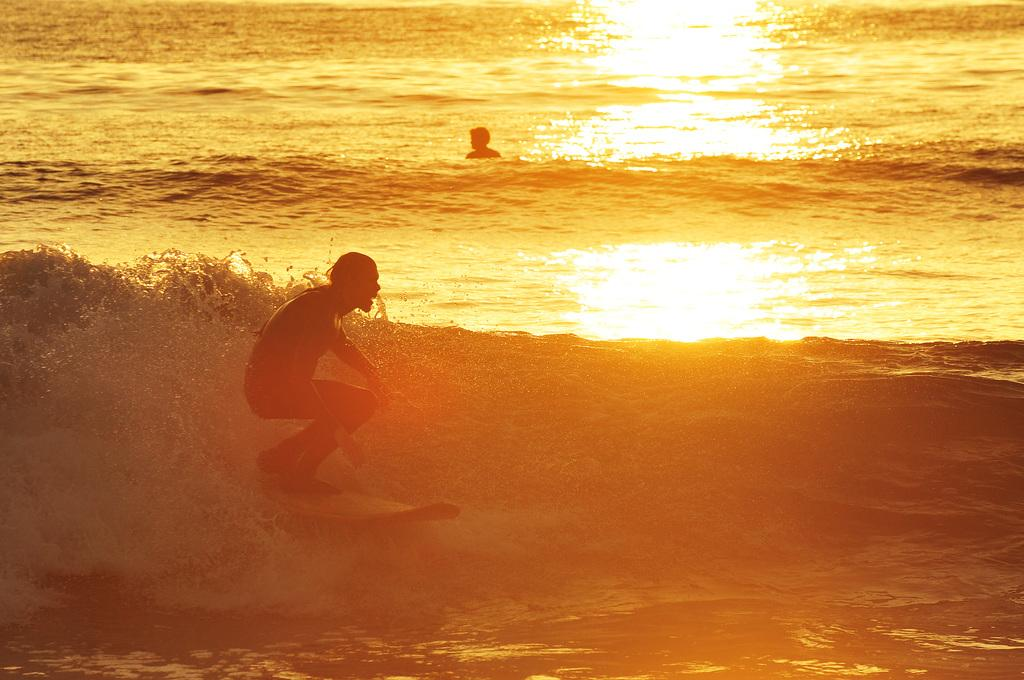What is the main activity being performed by the person in the image? The person is standing on a surfboard and surfing on the water. Can you describe the setting in which the person is surfing? The person is surfing on the water, which suggests they are near a body of water such as a beach or lake. Are there any other people visible in the image? Yes, there is another person visible in the image. What decision did the person make regarding their knee before getting on the surfboard? There is no information about any decisions made regarding the person's knee before getting on the surfboard, as the image only shows the person surfing. 